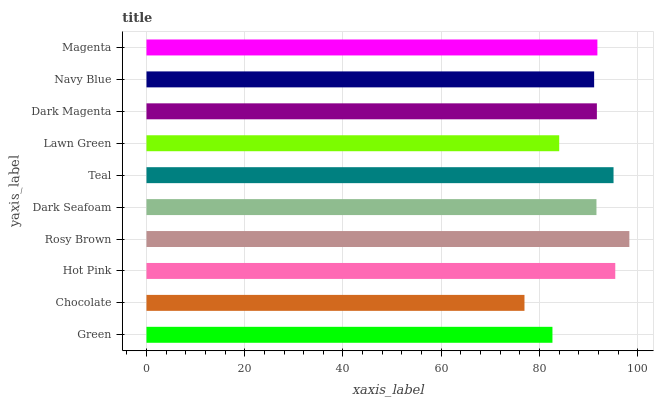Is Chocolate the minimum?
Answer yes or no. Yes. Is Rosy Brown the maximum?
Answer yes or no. Yes. Is Hot Pink the minimum?
Answer yes or no. No. Is Hot Pink the maximum?
Answer yes or no. No. Is Hot Pink greater than Chocolate?
Answer yes or no. Yes. Is Chocolate less than Hot Pink?
Answer yes or no. Yes. Is Chocolate greater than Hot Pink?
Answer yes or no. No. Is Hot Pink less than Chocolate?
Answer yes or no. No. Is Dark Magenta the high median?
Answer yes or no. Yes. Is Dark Seafoam the low median?
Answer yes or no. Yes. Is Hot Pink the high median?
Answer yes or no. No. Is Navy Blue the low median?
Answer yes or no. No. 